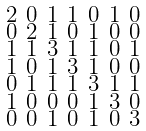<formula> <loc_0><loc_0><loc_500><loc_500>\begin{smallmatrix} 2 & 0 & 1 & 1 & 0 & 1 & 0 \\ 0 & 2 & 1 & 0 & 1 & 0 & 0 \\ 1 & 1 & 3 & 1 & 1 & 0 & 1 \\ 1 & 0 & 1 & 3 & 1 & 0 & 0 \\ 0 & 1 & 1 & 1 & 3 & 1 & 1 \\ 1 & 0 & 0 & 0 & 1 & 3 & 0 \\ 0 & 0 & 1 & 0 & 1 & 0 & 3 \end{smallmatrix}</formula> 